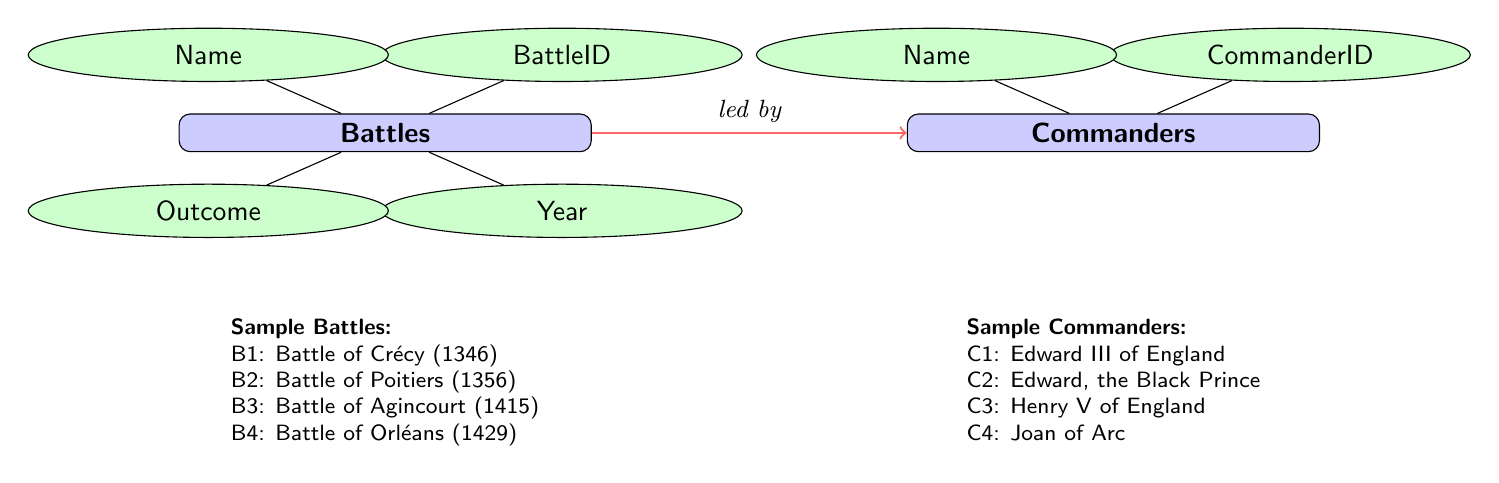What is the outcome of the Battle of Crécy? The diagram indicates that the Battle of Crécy resulted in an "English Victory." This information can be found under the outcome section for that specific battle.
Answer: English Victory Who were the commanders of the Battle of Poitiers? By examining the diagram, the connections indicate that the commanders associated with the Battle of Poitiers (B2) are Edward, the Black Prince (C2) and John II of France (C6). This information is derived from the connections between the Battles and Commanders entities.
Answer: Edward, the Black Prince and John II of France How many battles resulted in an English victory? The diagram shows that three battles—Crécy, Poitiers, and Agincourt—are marked as "English Victory." Thus, by counting these specific outcomes, we determine that three battles resulted in an English victory.
Answer: 3 Which battle was led by Joan of Arc? From the diagram, we can identify that Joan of Arc (C4) is associated with the Battle of Orléans (B4). This connection is specifically noted in the relationships outlined within the ER diagram.
Answer: Battle of Orléans What year did the Battle of Agincourt occur? The diagram lists the year associated with the Battle of Agincourt (B3), revealing that it took place in the year 1415. This information is part of the battle's attributes.
Answer: 1415 Which commander was involved in the largest number of battles according to the diagram? The diagram identifies each commander and their associated battles. A careful examination shows that there are four battles listed, each with different commanders associated, but each commander is tied to only one battle. Therefore, no commander is involved in multiple battles, indicating that all listed commanders participated in a single battle only.
Answer: No commander (each led one battle) What is the relationship between the Battles and Commanders entities? In the diagram, the relationship showcases that battles are "led by" commanders, which indicates the direct connection resulting in the battle outcomes being determined by the associated commanders. Thus, this specific relationship shows how battles and commanders influence each other.
Answer: Led by Which French commander was associated with the Battle of Crécy? Referring to the connections, the diagram indicates that Phillip VI of France (C5) was one of the commanders associated with the Battle of Crécy (B1). This information can be directly gleaned from the connections section of the diagram.
Answer: Phillip VI of France 